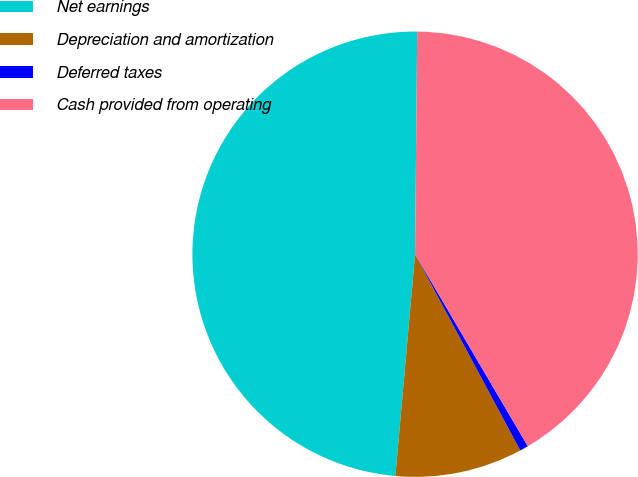Convert chart to OTSL. <chart><loc_0><loc_0><loc_500><loc_500><pie_chart><fcel>Net earnings<fcel>Depreciation and amortization<fcel>Deferred taxes<fcel>Cash provided from operating<nl><fcel>48.75%<fcel>9.24%<fcel>0.62%<fcel>41.4%<nl></chart> 